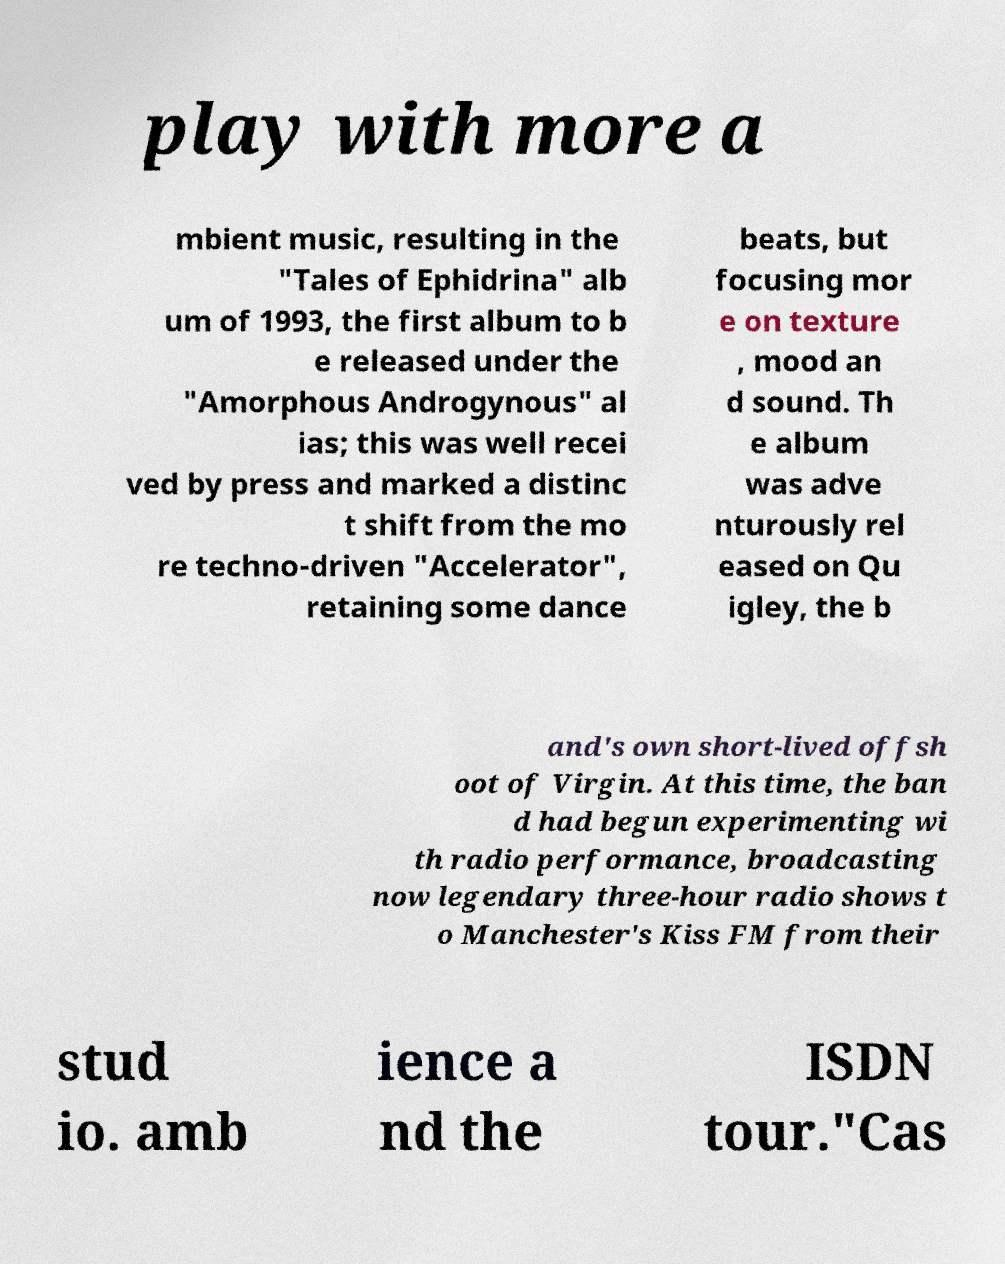There's text embedded in this image that I need extracted. Can you transcribe it verbatim? play with more a mbient music, resulting in the "Tales of Ephidrina" alb um of 1993, the first album to b e released under the "Amorphous Androgynous" al ias; this was well recei ved by press and marked a distinc t shift from the mo re techno-driven "Accelerator", retaining some dance beats, but focusing mor e on texture , mood an d sound. Th e album was adve nturously rel eased on Qu igley, the b and's own short-lived offsh oot of Virgin. At this time, the ban d had begun experimenting wi th radio performance, broadcasting now legendary three-hour radio shows t o Manchester's Kiss FM from their stud io. amb ience a nd the ISDN tour."Cas 